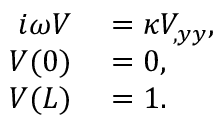Convert formula to latex. <formula><loc_0><loc_0><loc_500><loc_500>\begin{array} { r l } { i \omega V } & = \kappa V _ { , y y } , } \\ { V ( 0 ) } & = 0 , } \\ { V ( L ) } & = 1 . } \end{array}</formula> 